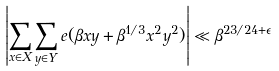Convert formula to latex. <formula><loc_0><loc_0><loc_500><loc_500>\left | \sum _ { x \in X } \sum _ { y \in Y } e ( \beta x y + \beta ^ { 1 / 3 } x ^ { 2 } y ^ { 2 } ) \right | \ll \beta ^ { 2 3 / 2 4 + \epsilon }</formula> 